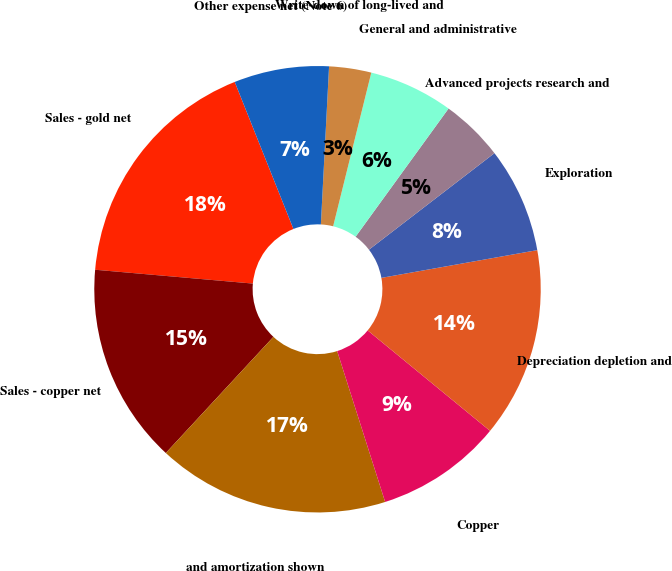<chart> <loc_0><loc_0><loc_500><loc_500><pie_chart><fcel>Sales - gold net<fcel>Sales - copper net<fcel>and amortization shown<fcel>Copper<fcel>Depreciation depletion and<fcel>Exploration<fcel>Advanced projects research and<fcel>General and administrative<fcel>Write-down of long-lived and<fcel>Other expense net (Note 6)<nl><fcel>17.56%<fcel>14.5%<fcel>16.79%<fcel>9.16%<fcel>13.74%<fcel>7.63%<fcel>4.58%<fcel>6.11%<fcel>3.05%<fcel>6.87%<nl></chart> 